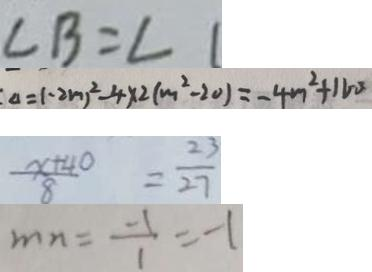<formula> <loc_0><loc_0><loc_500><loc_500>\angle B = \angle 1 
 \Delta = ( - 2 m ) ^ { 2 } - 4 \times 2 ( m ^ { 2 } - 2 0 ) = - 4 m ^ { 2 } + 1 6 0 
 \frac { x + 4 0 } { 8 } = \frac { 2 3 } { 2 7 } 
 m n = \frac { - 1 } { 1 } = - 1</formula> 